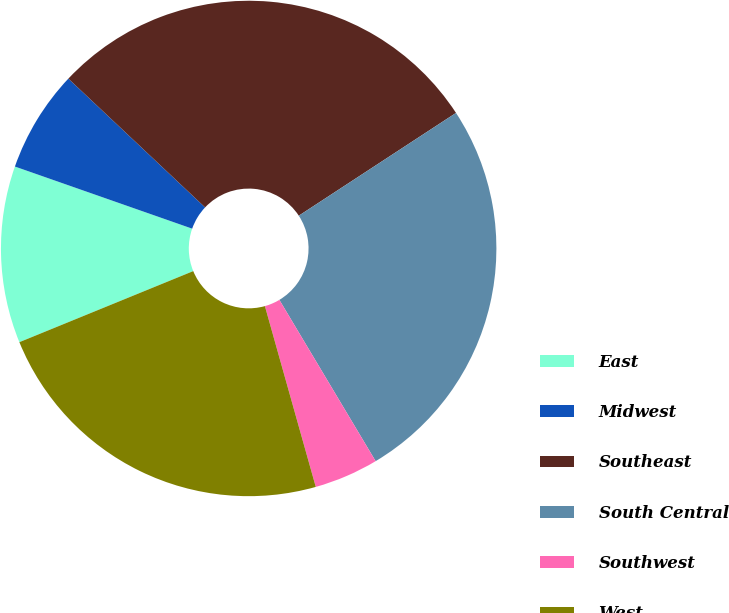<chart> <loc_0><loc_0><loc_500><loc_500><pie_chart><fcel>East<fcel>Midwest<fcel>Southeast<fcel>South Central<fcel>Southwest<fcel>West<nl><fcel>11.54%<fcel>6.66%<fcel>28.76%<fcel>25.65%<fcel>4.2%<fcel>23.19%<nl></chart> 